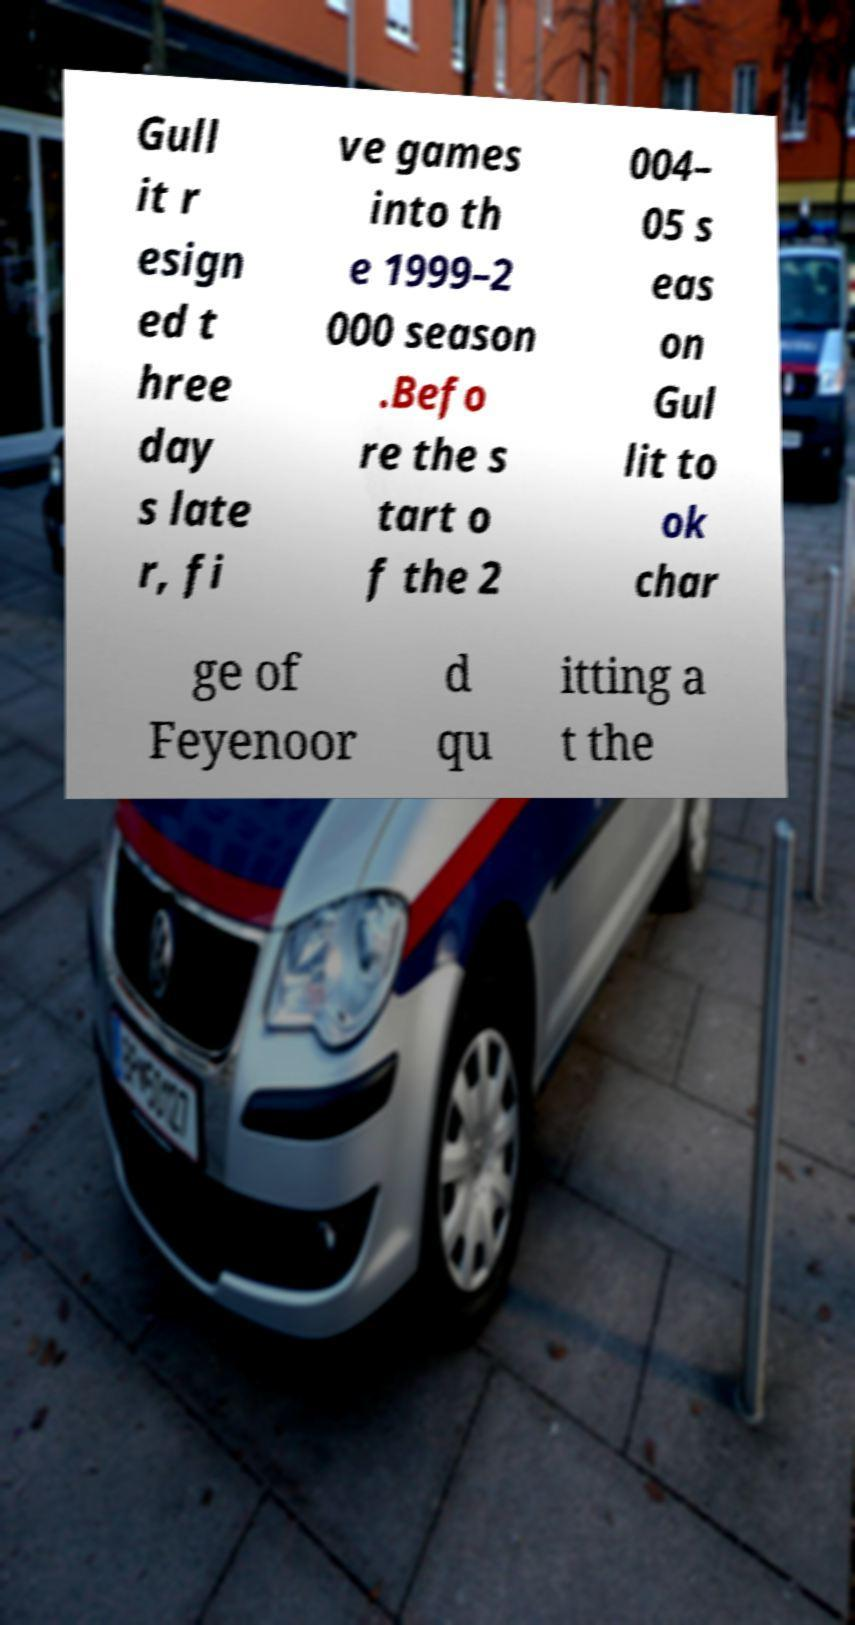Could you assist in decoding the text presented in this image and type it out clearly? Gull it r esign ed t hree day s late r, fi ve games into th e 1999–2 000 season .Befo re the s tart o f the 2 004– 05 s eas on Gul lit to ok char ge of Feyenoor d qu itting a t the 